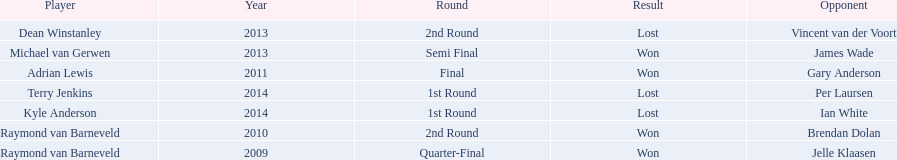Other than kyle anderson, who else lost in 2014? Terry Jenkins. 